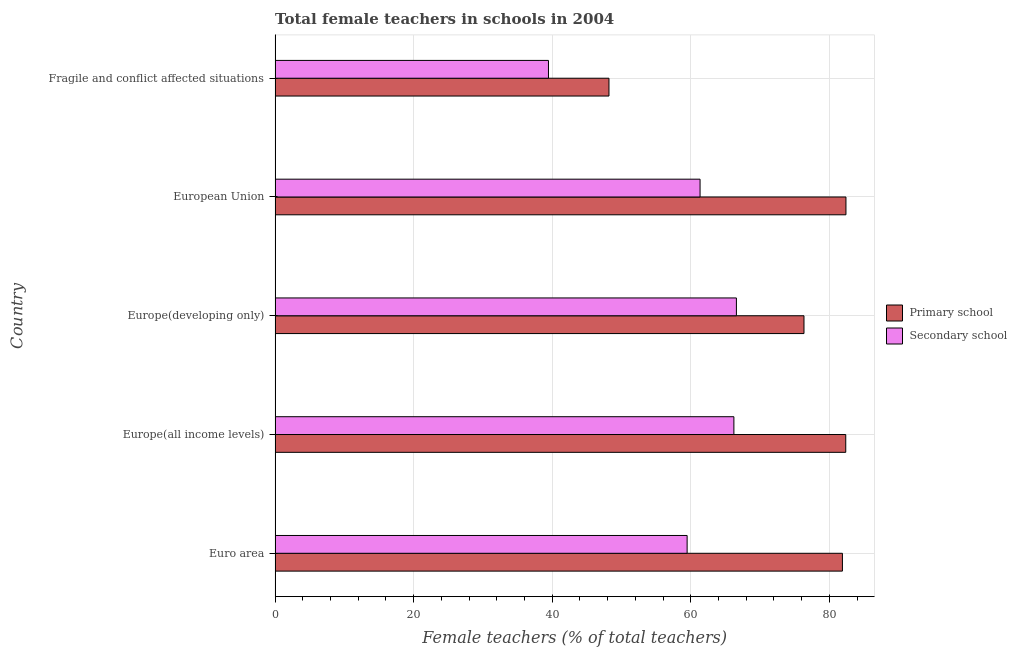How many groups of bars are there?
Your answer should be compact. 5. Are the number of bars on each tick of the Y-axis equal?
Provide a succinct answer. Yes. What is the label of the 4th group of bars from the top?
Ensure brevity in your answer.  Europe(all income levels). In how many cases, is the number of bars for a given country not equal to the number of legend labels?
Your response must be concise. 0. What is the percentage of female teachers in secondary schools in European Union?
Your answer should be very brief. 61.34. Across all countries, what is the maximum percentage of female teachers in primary schools?
Your response must be concise. 82.4. Across all countries, what is the minimum percentage of female teachers in secondary schools?
Give a very brief answer. 39.46. In which country was the percentage of female teachers in secondary schools maximum?
Your response must be concise. Europe(developing only). In which country was the percentage of female teachers in secondary schools minimum?
Ensure brevity in your answer.  Fragile and conflict affected situations. What is the total percentage of female teachers in primary schools in the graph?
Give a very brief answer. 371.21. What is the difference between the percentage of female teachers in primary schools in Euro area and that in Europe(all income levels)?
Offer a terse response. -0.48. What is the difference between the percentage of female teachers in primary schools in Europe(developing only) and the percentage of female teachers in secondary schools in Europe(all income levels)?
Keep it short and to the point. 10.12. What is the average percentage of female teachers in secondary schools per country?
Your answer should be very brief. 58.62. What is the difference between the percentage of female teachers in primary schools and percentage of female teachers in secondary schools in Europe(all income levels)?
Your answer should be very brief. 16.15. What is the ratio of the percentage of female teachers in primary schools in Euro area to that in Europe(developing only)?
Your answer should be compact. 1.07. Is the difference between the percentage of female teachers in primary schools in Europe(all income levels) and Europe(developing only) greater than the difference between the percentage of female teachers in secondary schools in Europe(all income levels) and Europe(developing only)?
Your response must be concise. Yes. What is the difference between the highest and the second highest percentage of female teachers in secondary schools?
Your answer should be compact. 0.36. What is the difference between the highest and the lowest percentage of female teachers in secondary schools?
Your response must be concise. 27.13. Is the sum of the percentage of female teachers in secondary schools in Europe(all income levels) and Europe(developing only) greater than the maximum percentage of female teachers in primary schools across all countries?
Your answer should be very brief. Yes. What does the 2nd bar from the top in Fragile and conflict affected situations represents?
Keep it short and to the point. Primary school. What does the 1st bar from the bottom in European Union represents?
Offer a terse response. Primary school. How many bars are there?
Ensure brevity in your answer.  10. How many countries are there in the graph?
Provide a succinct answer. 5. What is the difference between two consecutive major ticks on the X-axis?
Make the answer very short. 20. Does the graph contain any zero values?
Your answer should be compact. No. Does the graph contain grids?
Keep it short and to the point. Yes. Where does the legend appear in the graph?
Offer a terse response. Center right. How many legend labels are there?
Offer a terse response. 2. What is the title of the graph?
Provide a succinct answer. Total female teachers in schools in 2004. Does "Non-pregnant women" appear as one of the legend labels in the graph?
Ensure brevity in your answer.  No. What is the label or title of the X-axis?
Offer a very short reply. Female teachers (% of total teachers). What is the label or title of the Y-axis?
Provide a short and direct response. Country. What is the Female teachers (% of total teachers) of Primary school in Euro area?
Make the answer very short. 81.89. What is the Female teachers (% of total teachers) in Secondary school in Euro area?
Your response must be concise. 59.48. What is the Female teachers (% of total teachers) of Primary school in Europe(all income levels)?
Keep it short and to the point. 82.37. What is the Female teachers (% of total teachers) in Secondary school in Europe(all income levels)?
Offer a very short reply. 66.23. What is the Female teachers (% of total teachers) of Primary school in Europe(developing only)?
Offer a terse response. 76.35. What is the Female teachers (% of total teachers) of Secondary school in Europe(developing only)?
Offer a terse response. 66.59. What is the Female teachers (% of total teachers) of Primary school in European Union?
Give a very brief answer. 82.4. What is the Female teachers (% of total teachers) of Secondary school in European Union?
Offer a terse response. 61.34. What is the Female teachers (% of total teachers) in Primary school in Fragile and conflict affected situations?
Give a very brief answer. 48.19. What is the Female teachers (% of total teachers) of Secondary school in Fragile and conflict affected situations?
Ensure brevity in your answer.  39.46. Across all countries, what is the maximum Female teachers (% of total teachers) in Primary school?
Give a very brief answer. 82.4. Across all countries, what is the maximum Female teachers (% of total teachers) of Secondary school?
Make the answer very short. 66.59. Across all countries, what is the minimum Female teachers (% of total teachers) of Primary school?
Your response must be concise. 48.19. Across all countries, what is the minimum Female teachers (% of total teachers) of Secondary school?
Keep it short and to the point. 39.46. What is the total Female teachers (% of total teachers) of Primary school in the graph?
Provide a succinct answer. 371.21. What is the total Female teachers (% of total teachers) in Secondary school in the graph?
Offer a terse response. 293.1. What is the difference between the Female teachers (% of total teachers) of Primary school in Euro area and that in Europe(all income levels)?
Offer a terse response. -0.48. What is the difference between the Female teachers (% of total teachers) of Secondary school in Euro area and that in Europe(all income levels)?
Your answer should be very brief. -6.75. What is the difference between the Female teachers (% of total teachers) in Primary school in Euro area and that in Europe(developing only)?
Your response must be concise. 5.55. What is the difference between the Female teachers (% of total teachers) of Secondary school in Euro area and that in Europe(developing only)?
Make the answer very short. -7.11. What is the difference between the Female teachers (% of total teachers) of Primary school in Euro area and that in European Union?
Ensure brevity in your answer.  -0.51. What is the difference between the Female teachers (% of total teachers) in Secondary school in Euro area and that in European Union?
Provide a succinct answer. -1.87. What is the difference between the Female teachers (% of total teachers) of Primary school in Euro area and that in Fragile and conflict affected situations?
Provide a short and direct response. 33.7. What is the difference between the Female teachers (% of total teachers) of Secondary school in Euro area and that in Fragile and conflict affected situations?
Give a very brief answer. 20.01. What is the difference between the Female teachers (% of total teachers) of Primary school in Europe(all income levels) and that in Europe(developing only)?
Ensure brevity in your answer.  6.03. What is the difference between the Female teachers (% of total teachers) in Secondary school in Europe(all income levels) and that in Europe(developing only)?
Ensure brevity in your answer.  -0.36. What is the difference between the Female teachers (% of total teachers) in Primary school in Europe(all income levels) and that in European Union?
Provide a short and direct response. -0.03. What is the difference between the Female teachers (% of total teachers) of Secondary school in Europe(all income levels) and that in European Union?
Offer a terse response. 4.88. What is the difference between the Female teachers (% of total teachers) in Primary school in Europe(all income levels) and that in Fragile and conflict affected situations?
Give a very brief answer. 34.18. What is the difference between the Female teachers (% of total teachers) in Secondary school in Europe(all income levels) and that in Fragile and conflict affected situations?
Offer a terse response. 26.76. What is the difference between the Female teachers (% of total teachers) in Primary school in Europe(developing only) and that in European Union?
Offer a very short reply. -6.06. What is the difference between the Female teachers (% of total teachers) of Secondary school in Europe(developing only) and that in European Union?
Your answer should be very brief. 5.25. What is the difference between the Female teachers (% of total teachers) in Primary school in Europe(developing only) and that in Fragile and conflict affected situations?
Provide a succinct answer. 28.15. What is the difference between the Female teachers (% of total teachers) of Secondary school in Europe(developing only) and that in Fragile and conflict affected situations?
Ensure brevity in your answer.  27.13. What is the difference between the Female teachers (% of total teachers) of Primary school in European Union and that in Fragile and conflict affected situations?
Keep it short and to the point. 34.21. What is the difference between the Female teachers (% of total teachers) in Secondary school in European Union and that in Fragile and conflict affected situations?
Ensure brevity in your answer.  21.88. What is the difference between the Female teachers (% of total teachers) of Primary school in Euro area and the Female teachers (% of total teachers) of Secondary school in Europe(all income levels)?
Keep it short and to the point. 15.67. What is the difference between the Female teachers (% of total teachers) of Primary school in Euro area and the Female teachers (% of total teachers) of Secondary school in Europe(developing only)?
Make the answer very short. 15.3. What is the difference between the Female teachers (% of total teachers) in Primary school in Euro area and the Female teachers (% of total teachers) in Secondary school in European Union?
Offer a terse response. 20.55. What is the difference between the Female teachers (% of total teachers) of Primary school in Euro area and the Female teachers (% of total teachers) of Secondary school in Fragile and conflict affected situations?
Give a very brief answer. 42.43. What is the difference between the Female teachers (% of total teachers) in Primary school in Europe(all income levels) and the Female teachers (% of total teachers) in Secondary school in Europe(developing only)?
Make the answer very short. 15.78. What is the difference between the Female teachers (% of total teachers) of Primary school in Europe(all income levels) and the Female teachers (% of total teachers) of Secondary school in European Union?
Ensure brevity in your answer.  21.03. What is the difference between the Female teachers (% of total teachers) of Primary school in Europe(all income levels) and the Female teachers (% of total teachers) of Secondary school in Fragile and conflict affected situations?
Provide a succinct answer. 42.91. What is the difference between the Female teachers (% of total teachers) of Primary school in Europe(developing only) and the Female teachers (% of total teachers) of Secondary school in European Union?
Your response must be concise. 15. What is the difference between the Female teachers (% of total teachers) in Primary school in Europe(developing only) and the Female teachers (% of total teachers) in Secondary school in Fragile and conflict affected situations?
Give a very brief answer. 36.88. What is the difference between the Female teachers (% of total teachers) of Primary school in European Union and the Female teachers (% of total teachers) of Secondary school in Fragile and conflict affected situations?
Offer a very short reply. 42.94. What is the average Female teachers (% of total teachers) of Primary school per country?
Provide a succinct answer. 74.24. What is the average Female teachers (% of total teachers) in Secondary school per country?
Provide a short and direct response. 58.62. What is the difference between the Female teachers (% of total teachers) in Primary school and Female teachers (% of total teachers) in Secondary school in Euro area?
Give a very brief answer. 22.42. What is the difference between the Female teachers (% of total teachers) in Primary school and Female teachers (% of total teachers) in Secondary school in Europe(all income levels)?
Your response must be concise. 16.15. What is the difference between the Female teachers (% of total teachers) of Primary school and Female teachers (% of total teachers) of Secondary school in Europe(developing only)?
Your answer should be very brief. 9.76. What is the difference between the Female teachers (% of total teachers) of Primary school and Female teachers (% of total teachers) of Secondary school in European Union?
Give a very brief answer. 21.06. What is the difference between the Female teachers (% of total teachers) of Primary school and Female teachers (% of total teachers) of Secondary school in Fragile and conflict affected situations?
Your answer should be compact. 8.73. What is the ratio of the Female teachers (% of total teachers) of Secondary school in Euro area to that in Europe(all income levels)?
Give a very brief answer. 0.9. What is the ratio of the Female teachers (% of total teachers) in Primary school in Euro area to that in Europe(developing only)?
Your response must be concise. 1.07. What is the ratio of the Female teachers (% of total teachers) of Secondary school in Euro area to that in Europe(developing only)?
Ensure brevity in your answer.  0.89. What is the ratio of the Female teachers (% of total teachers) of Secondary school in Euro area to that in European Union?
Your answer should be compact. 0.97. What is the ratio of the Female teachers (% of total teachers) of Primary school in Euro area to that in Fragile and conflict affected situations?
Offer a terse response. 1.7. What is the ratio of the Female teachers (% of total teachers) in Secondary school in Euro area to that in Fragile and conflict affected situations?
Offer a terse response. 1.51. What is the ratio of the Female teachers (% of total teachers) in Primary school in Europe(all income levels) to that in Europe(developing only)?
Provide a short and direct response. 1.08. What is the ratio of the Female teachers (% of total teachers) in Secondary school in Europe(all income levels) to that in Europe(developing only)?
Your response must be concise. 0.99. What is the ratio of the Female teachers (% of total teachers) in Secondary school in Europe(all income levels) to that in European Union?
Keep it short and to the point. 1.08. What is the ratio of the Female teachers (% of total teachers) in Primary school in Europe(all income levels) to that in Fragile and conflict affected situations?
Offer a very short reply. 1.71. What is the ratio of the Female teachers (% of total teachers) in Secondary school in Europe(all income levels) to that in Fragile and conflict affected situations?
Make the answer very short. 1.68. What is the ratio of the Female teachers (% of total teachers) of Primary school in Europe(developing only) to that in European Union?
Give a very brief answer. 0.93. What is the ratio of the Female teachers (% of total teachers) in Secondary school in Europe(developing only) to that in European Union?
Your answer should be compact. 1.09. What is the ratio of the Female teachers (% of total teachers) of Primary school in Europe(developing only) to that in Fragile and conflict affected situations?
Provide a succinct answer. 1.58. What is the ratio of the Female teachers (% of total teachers) in Secondary school in Europe(developing only) to that in Fragile and conflict affected situations?
Offer a terse response. 1.69. What is the ratio of the Female teachers (% of total teachers) of Primary school in European Union to that in Fragile and conflict affected situations?
Give a very brief answer. 1.71. What is the ratio of the Female teachers (% of total teachers) in Secondary school in European Union to that in Fragile and conflict affected situations?
Your answer should be very brief. 1.55. What is the difference between the highest and the second highest Female teachers (% of total teachers) in Primary school?
Provide a short and direct response. 0.03. What is the difference between the highest and the second highest Female teachers (% of total teachers) of Secondary school?
Offer a terse response. 0.36. What is the difference between the highest and the lowest Female teachers (% of total teachers) of Primary school?
Provide a succinct answer. 34.21. What is the difference between the highest and the lowest Female teachers (% of total teachers) of Secondary school?
Your response must be concise. 27.13. 